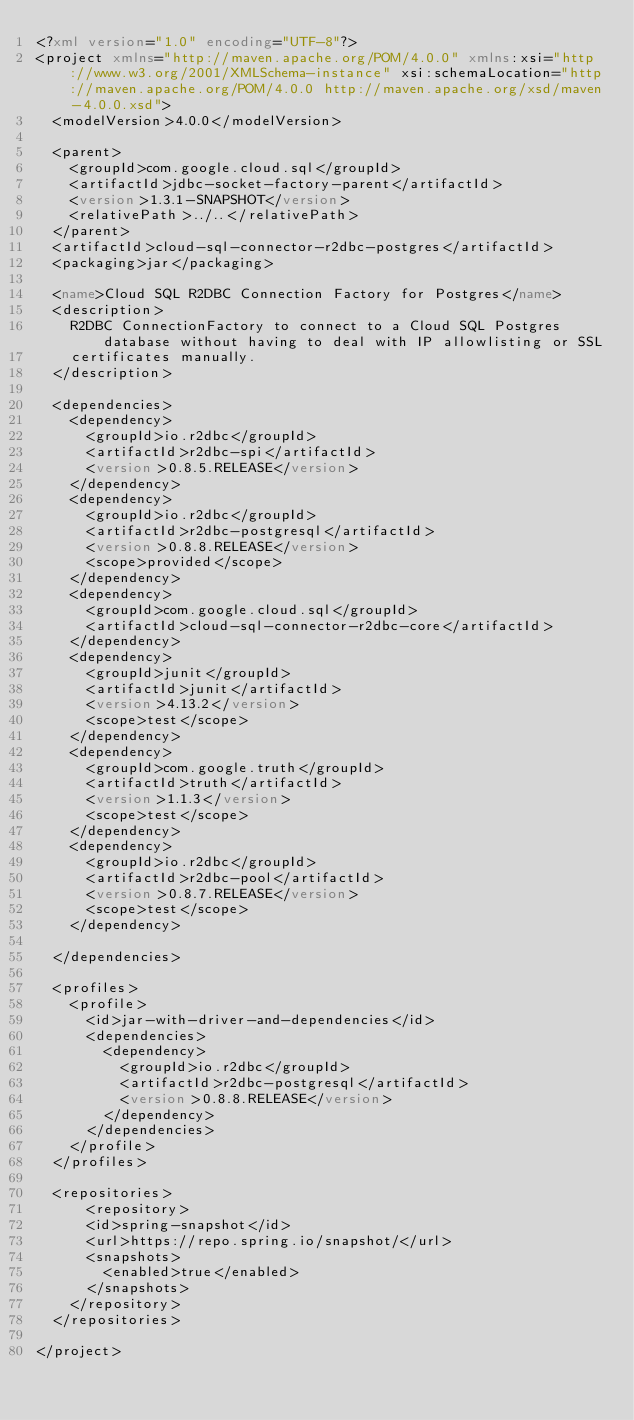Convert code to text. <code><loc_0><loc_0><loc_500><loc_500><_XML_><?xml version="1.0" encoding="UTF-8"?>
<project xmlns="http://maven.apache.org/POM/4.0.0" xmlns:xsi="http://www.w3.org/2001/XMLSchema-instance" xsi:schemaLocation="http://maven.apache.org/POM/4.0.0 http://maven.apache.org/xsd/maven-4.0.0.xsd">
  <modelVersion>4.0.0</modelVersion>

  <parent>
    <groupId>com.google.cloud.sql</groupId>
    <artifactId>jdbc-socket-factory-parent</artifactId>
    <version>1.3.1-SNAPSHOT</version>
    <relativePath>../..</relativePath>
  </parent>
  <artifactId>cloud-sql-connector-r2dbc-postgres</artifactId>
  <packaging>jar</packaging>

  <name>Cloud SQL R2DBC Connection Factory for Postgres</name>
  <description>
    R2DBC ConnectionFactory to connect to a Cloud SQL Postgres database without having to deal with IP allowlisting or SSL
    certificates manually.
  </description>

  <dependencies>
    <dependency>
      <groupId>io.r2dbc</groupId>
      <artifactId>r2dbc-spi</artifactId>
      <version>0.8.5.RELEASE</version>
    </dependency>
    <dependency>
      <groupId>io.r2dbc</groupId>
      <artifactId>r2dbc-postgresql</artifactId>
      <version>0.8.8.RELEASE</version>
      <scope>provided</scope>
    </dependency>
    <dependency>
      <groupId>com.google.cloud.sql</groupId>
      <artifactId>cloud-sql-connector-r2dbc-core</artifactId>
    </dependency>
    <dependency>
      <groupId>junit</groupId>
      <artifactId>junit</artifactId>
      <version>4.13.2</version>
      <scope>test</scope>
    </dependency>
    <dependency>
      <groupId>com.google.truth</groupId>
      <artifactId>truth</artifactId>
      <version>1.1.3</version>
      <scope>test</scope>
    </dependency>
    <dependency>
      <groupId>io.r2dbc</groupId>
      <artifactId>r2dbc-pool</artifactId>
      <version>0.8.7.RELEASE</version>
      <scope>test</scope>
    </dependency>

  </dependencies>

  <profiles>
    <profile>
      <id>jar-with-driver-and-dependencies</id>
      <dependencies>
        <dependency>
          <groupId>io.r2dbc</groupId>
          <artifactId>r2dbc-postgresql</artifactId>
          <version>0.8.8.RELEASE</version>
        </dependency>
      </dependencies>
    </profile>
  </profiles>

  <repositories>
	  <repository>
      <id>spring-snapshot</id>
      <url>https://repo.spring.io/snapshot/</url>
      <snapshots>
        <enabled>true</enabled>
      </snapshots>
    </repository>
  </repositories>

</project>
</code> 